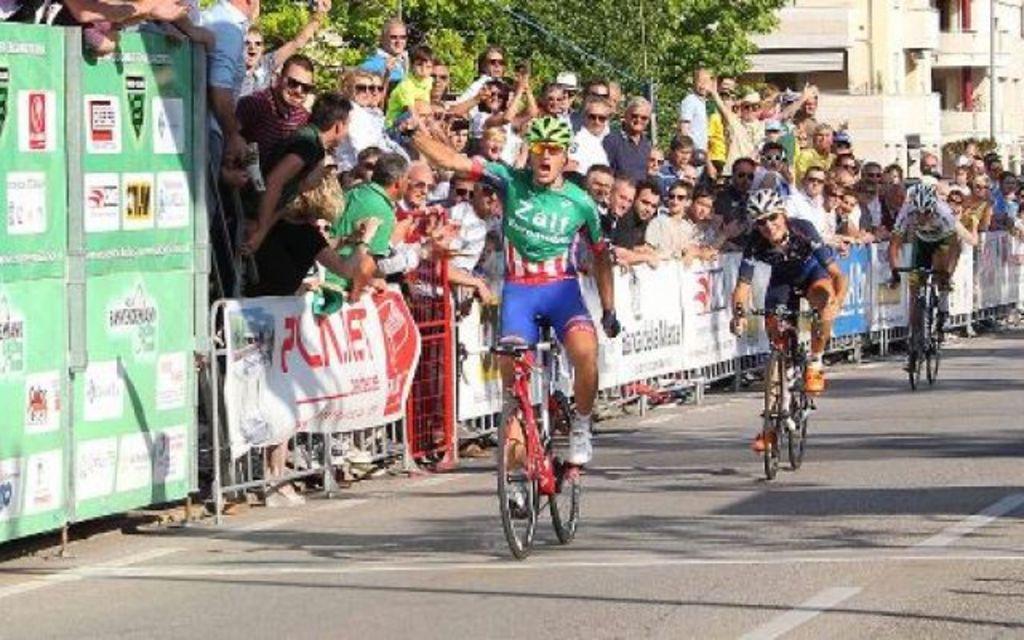What does it say on the man's green shirt?
Your answer should be compact. Zalf. 